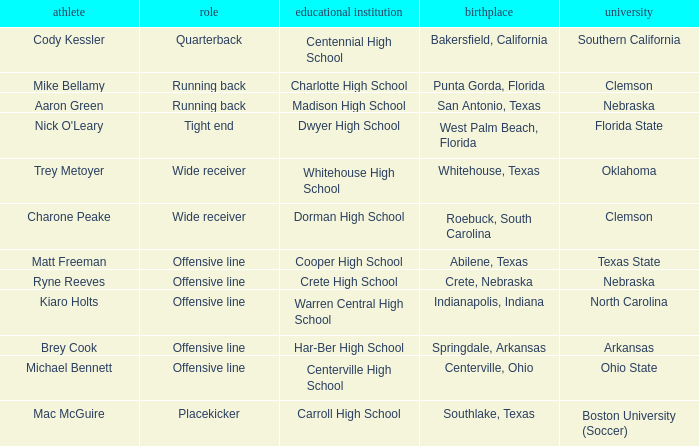What was the position of the player that went to warren central high school? Offensive line. 